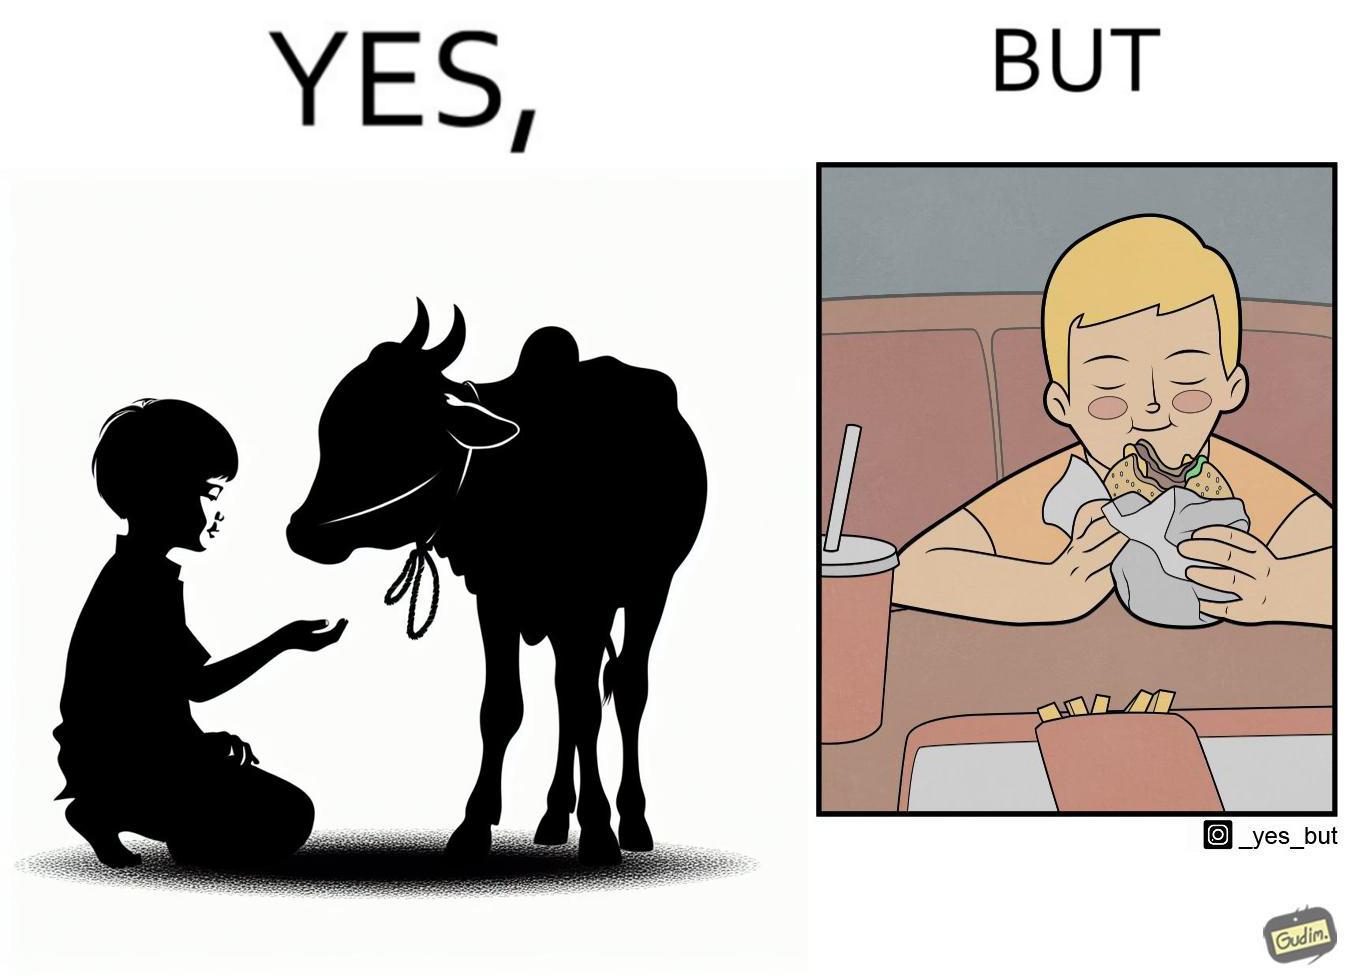What is the satirical meaning behind this image? The irony is that the boy is petting the cow to show that he cares about the animal, but then he also eats hamburgers made from the same cows 